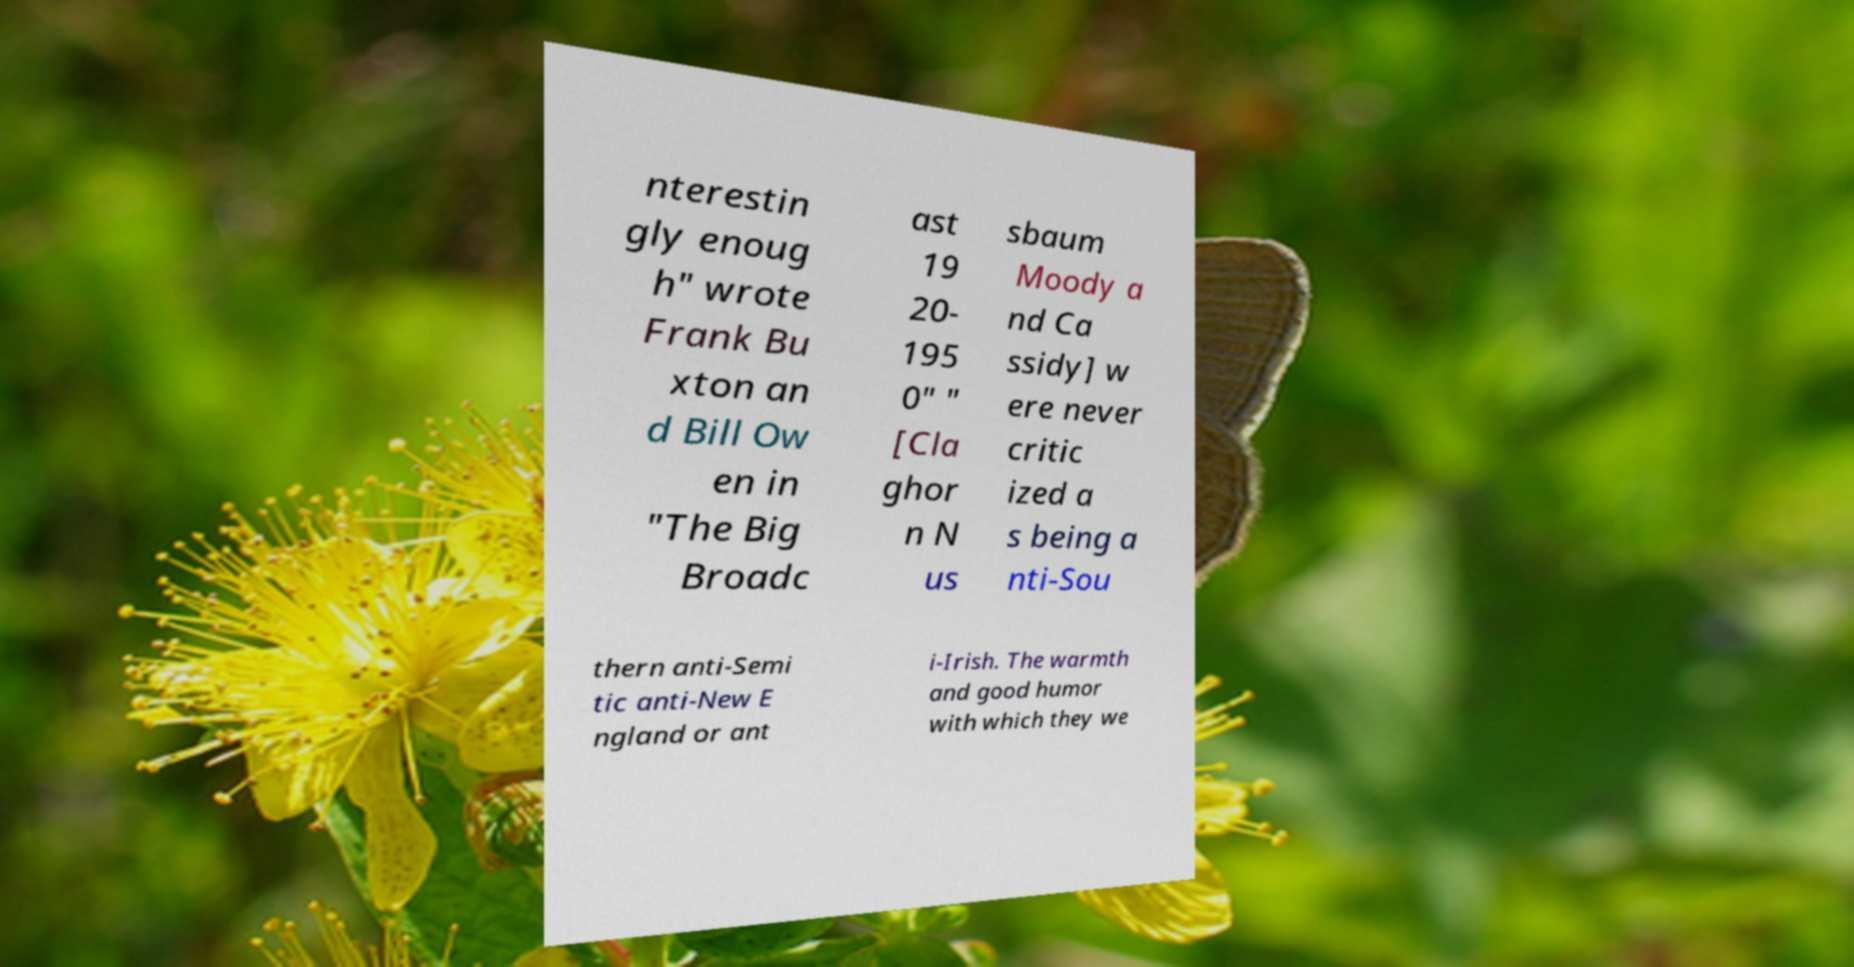Could you extract and type out the text from this image? nterestin gly enoug h" wrote Frank Bu xton an d Bill Ow en in "The Big Broadc ast 19 20- 195 0" " [Cla ghor n N us sbaum Moody a nd Ca ssidy] w ere never critic ized a s being a nti-Sou thern anti-Semi tic anti-New E ngland or ant i-Irish. The warmth and good humor with which they we 